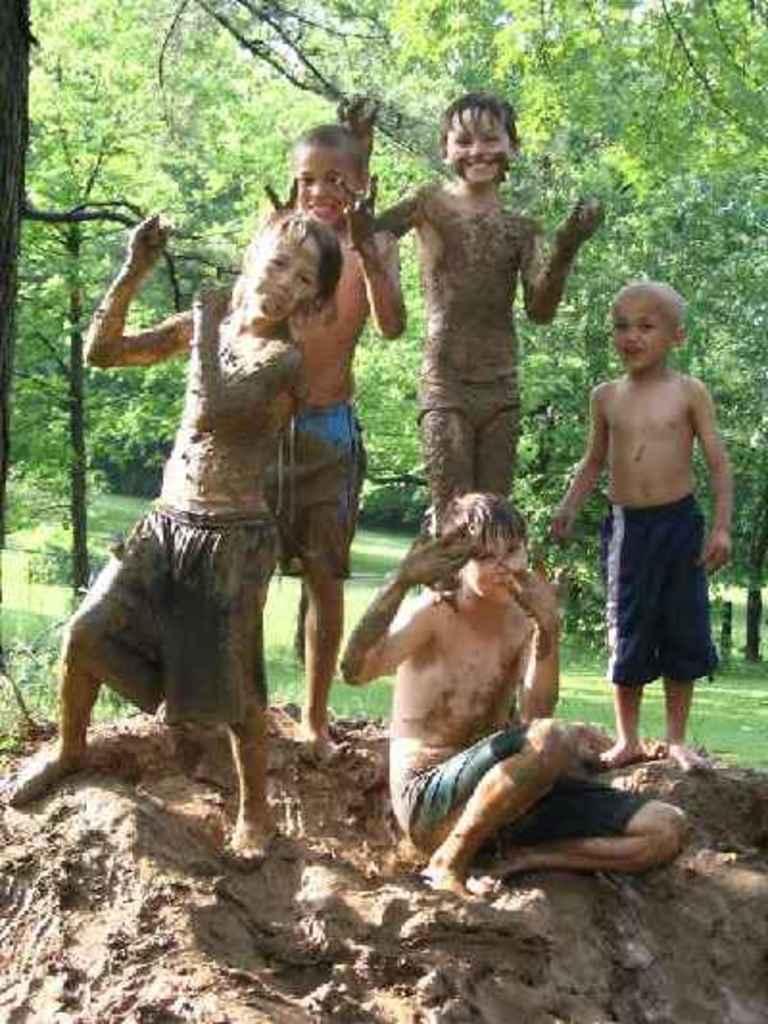Please provide a concise description of this image. There are 5 people covered with mud. A person is sitting on the mud and other 4 are standing. Behind them there are trees. 